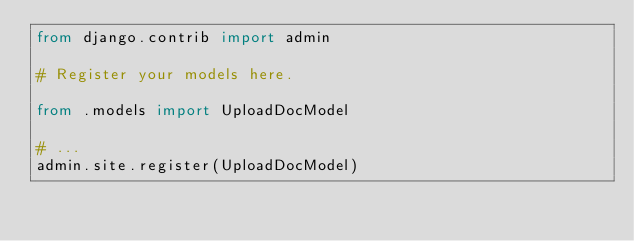Convert code to text. <code><loc_0><loc_0><loc_500><loc_500><_Python_>from django.contrib import admin

# Register your models here.

from .models import UploadDocModel

# ...
admin.site.register(UploadDocModel)
</code> 